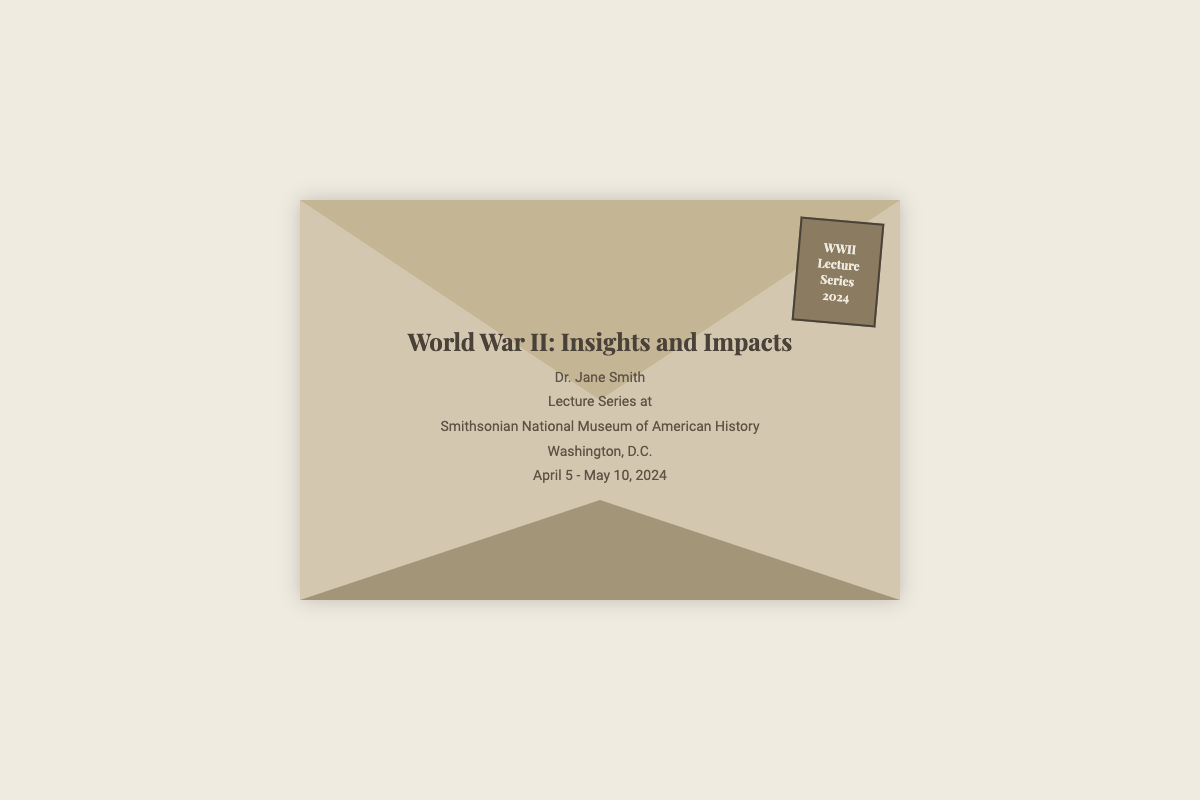what is the title of the lecture series? The title is presented prominently at the top of the document.
Answer: World War II: Insights and Impacts who is the lecturer? The lecturer's name is included below the title in the document.
Answer: Dr. Jane Smith where will the lecture series be held? The document specifies the location of the event.
Answer: Smithsonian National Museum of American History when does the lecture series take place? The dates for the lecture series are stated in the content section.
Answer: April 5 - May 10, 2024 what city is the museum located in? The city is mentioned alongside the museum's name in the document.
Answer: Washington, D.C what type of event is this document describing? The document describes a specific type of educational event.
Answer: Lecture Series what is the purpose of the stamp on the envelope? The stamp indicates the theme and year of the event as detailed in the document.
Answer: WWII Lecture Series 2024 how many weeks does the lecture series span? The duration of the lecture series can be calculated from the given dates.
Answer: 5 weeks what design elements are used in the envelope? The design elements are reflected in the colors and style of the envelope layout.
Answer: Colorful gradient, borders, and shadow effects 